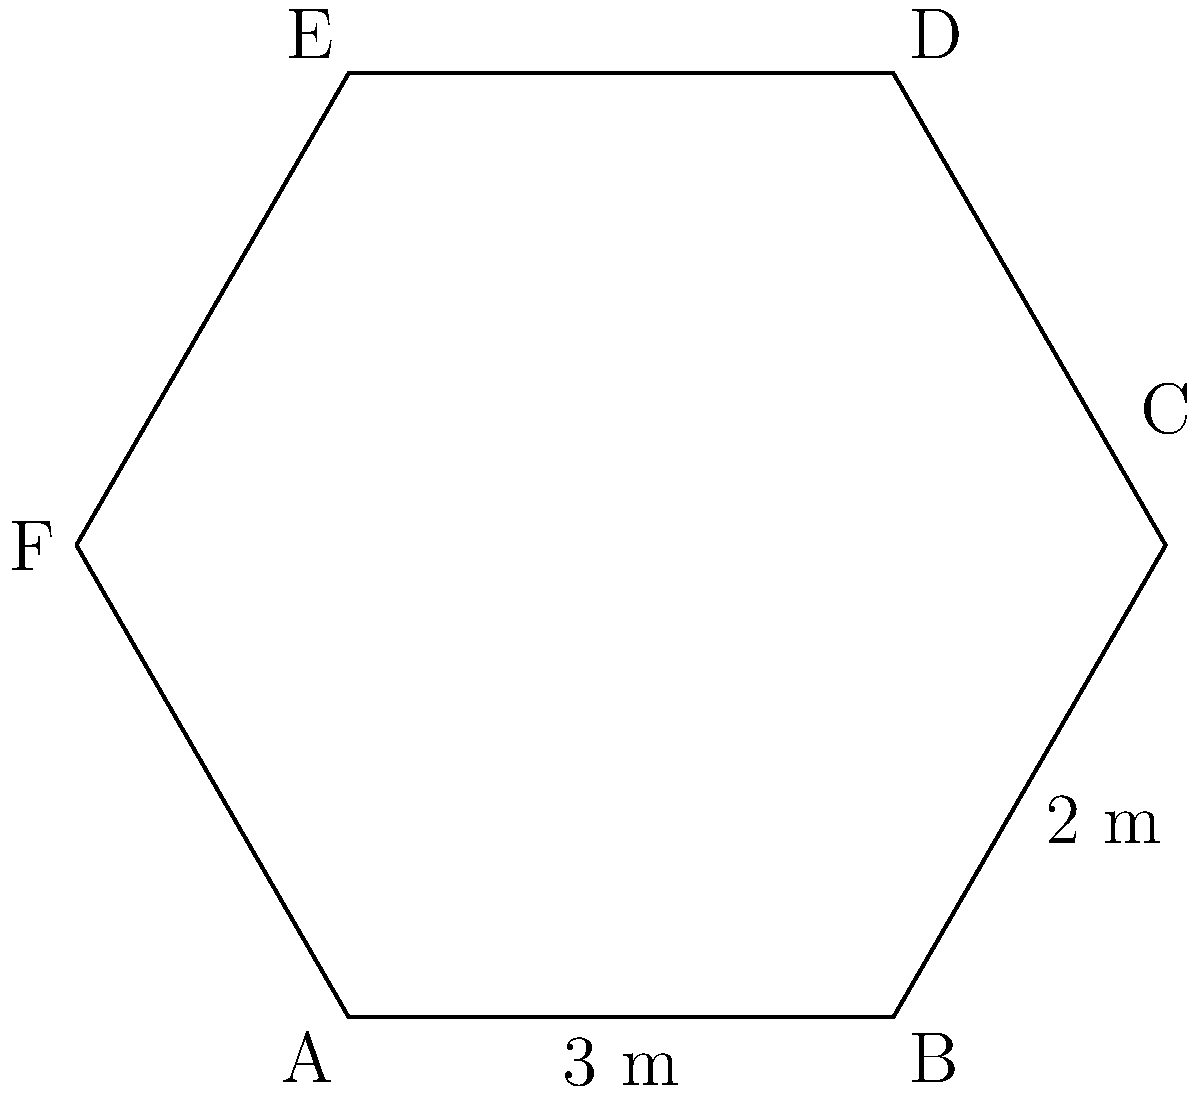A hexagonal isolation chamber is being designed for COVID-19 patients. The chamber has the shape of a regular hexagon. If the length of one side is 3 meters and the distance between two parallel sides is 5.2 meters, what is the perimeter of the isolation chamber? Let's approach this step-by-step:

1) In a regular hexagon, all sides are equal in length. We're given that one side is 3 meters long.

2) To find the perimeter, we need to multiply the length of one side by 6 (as there are 6 sides in a hexagon).

3) Perimeter = 6 * side length
             = 6 * 3 meters

4) Perimeter = 18 meters

Note: The distance between parallel sides (5.2 meters) is not directly used in this calculation, but it confirms that this is indeed a regular hexagon. In a regular hexagon, the distance between parallel sides (called the height) is related to the side length (s) by the formula:

$$ h = s * \sqrt{3} $$

We can verify:
$$ 5.2 \approx 3 * \sqrt{3} \approx 5.196 $$

This slight difference (5.2 vs 5.196) is likely due to rounding in the given measurements.
Answer: 18 meters 